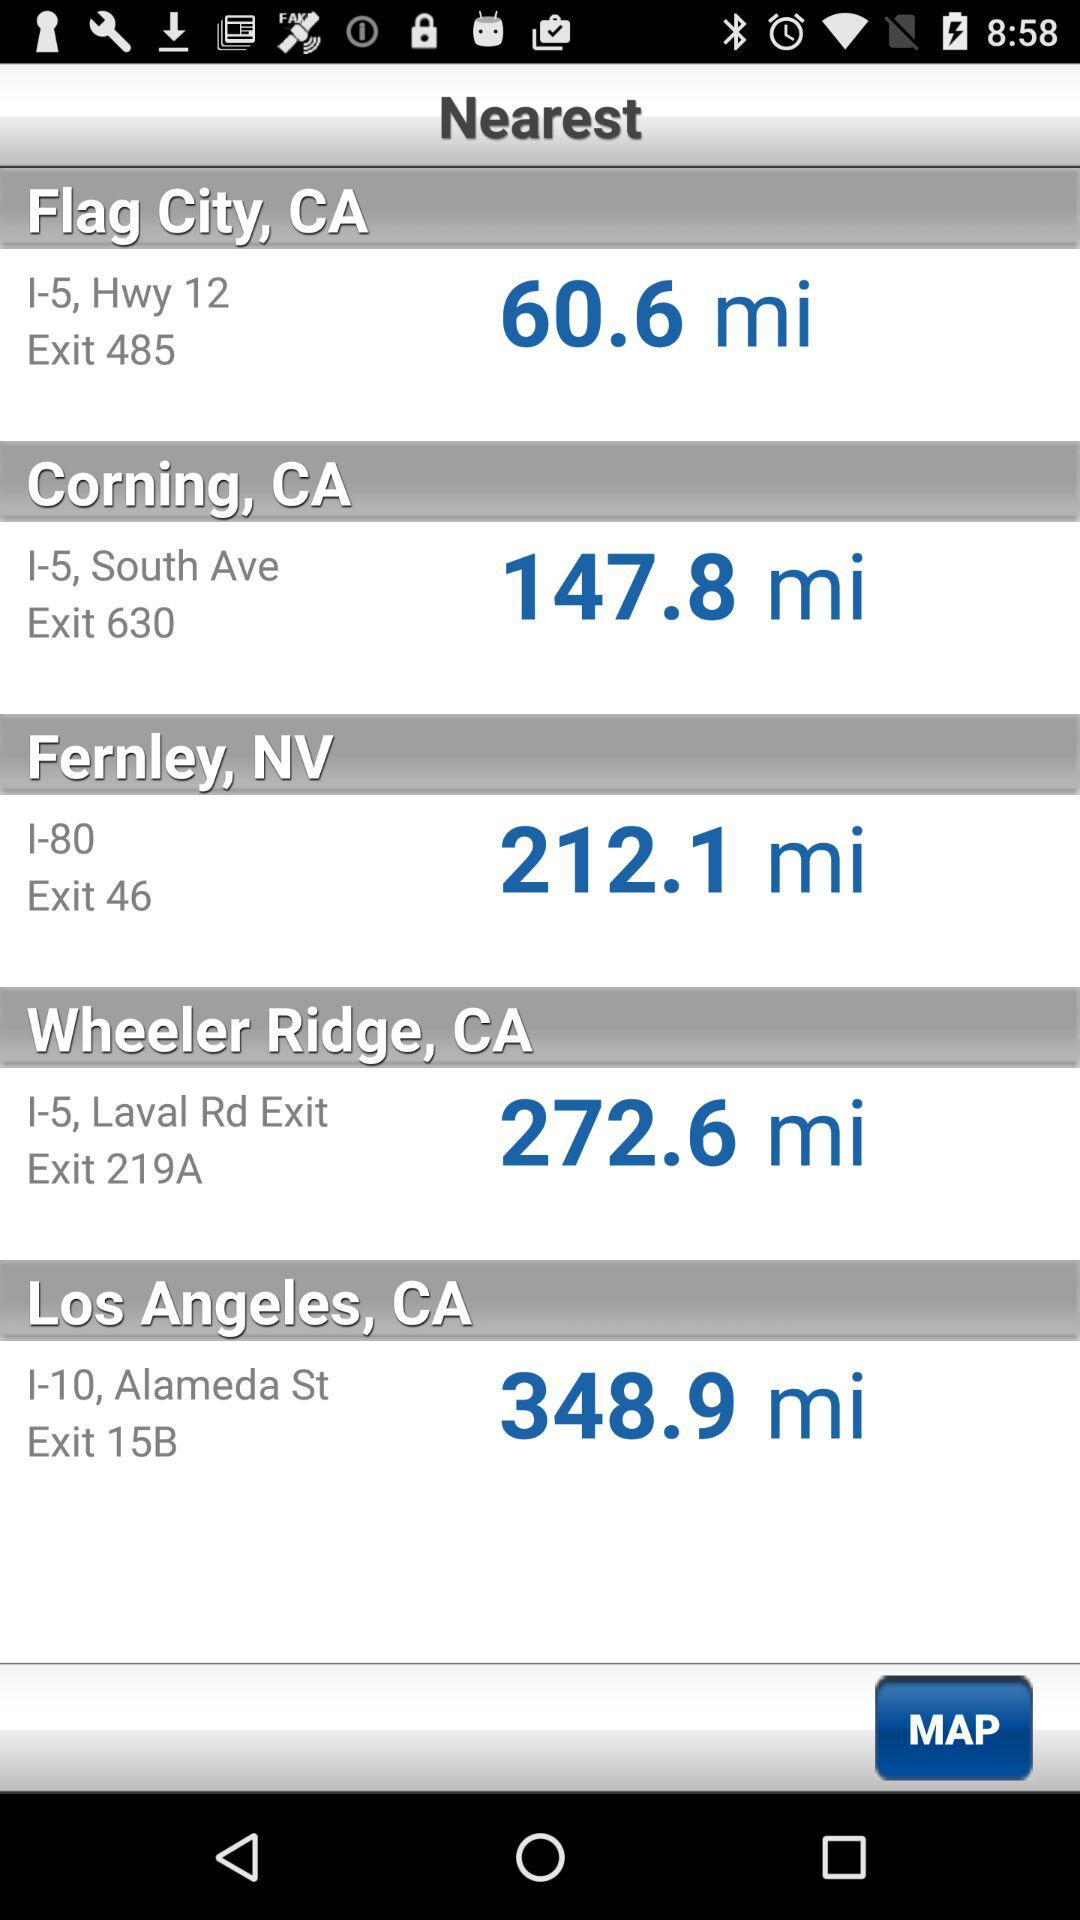What is the exit for Los Angeles, CA? The exit for Los Angeles, CA is 15B. 